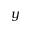Convert formula to latex. <formula><loc_0><loc_0><loc_500><loc_500>y</formula> 